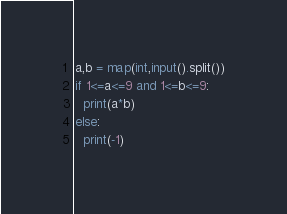Convert code to text. <code><loc_0><loc_0><loc_500><loc_500><_Python_>a,b = map(int,input().split())
if 1<=a<=9 and 1<=b<=9:
  print(a*b)
else:
  print(-1)
</code> 